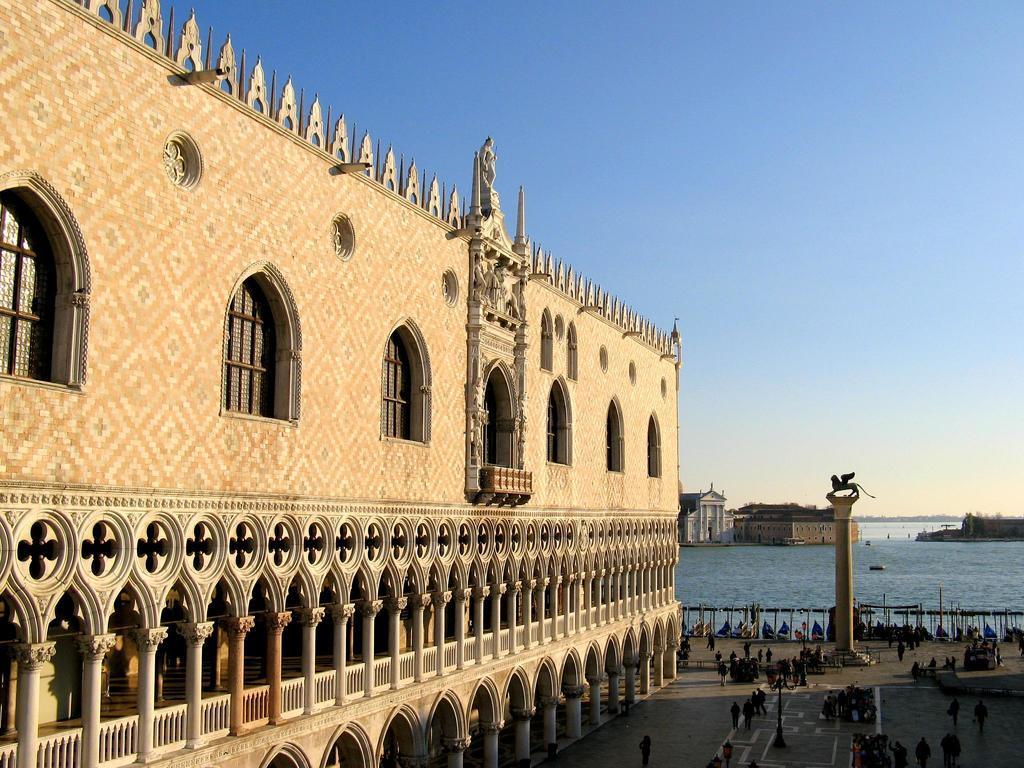In one or two sentences, can you explain what this image depicts? In this image we can see a building. On the buildings we can see the windows, pillars, and a sculpture. On the left side, we can see a group of persons, a pillar and water. Behind the water we can see few buildings. At the top we can see the sky. 